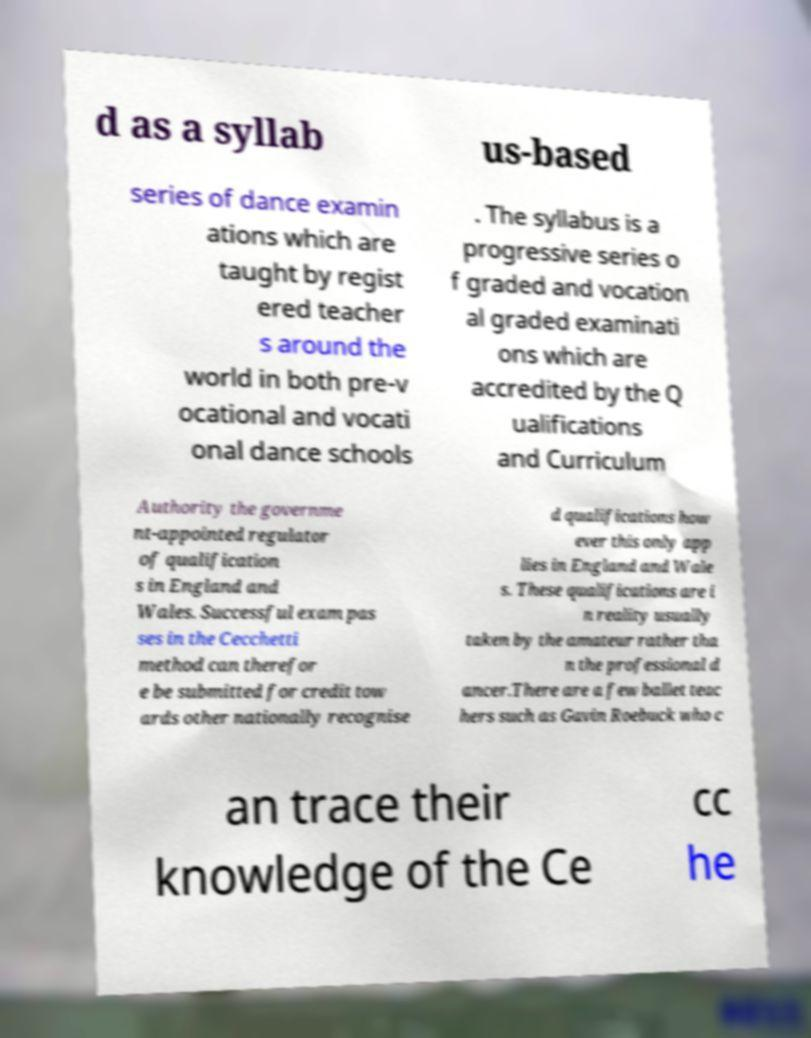I need the written content from this picture converted into text. Can you do that? d as a syllab us-based series of dance examin ations which are taught by regist ered teacher s around the world in both pre-v ocational and vocati onal dance schools . The syllabus is a progressive series o f graded and vocation al graded examinati ons which are accredited by the Q ualifications and Curriculum Authority the governme nt-appointed regulator of qualification s in England and Wales. Successful exam pas ses in the Cecchetti method can therefor e be submitted for credit tow ards other nationally recognise d qualifications how ever this only app lies in England and Wale s. These qualifications are i n reality usually taken by the amateur rather tha n the professional d ancer.There are a few ballet teac hers such as Gavin Roebuck who c an trace their knowledge of the Ce cc he 